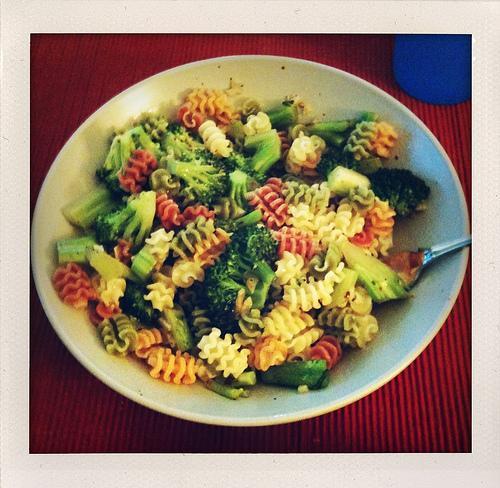How many colors of pasta are there?
Give a very brief answer. 4. 